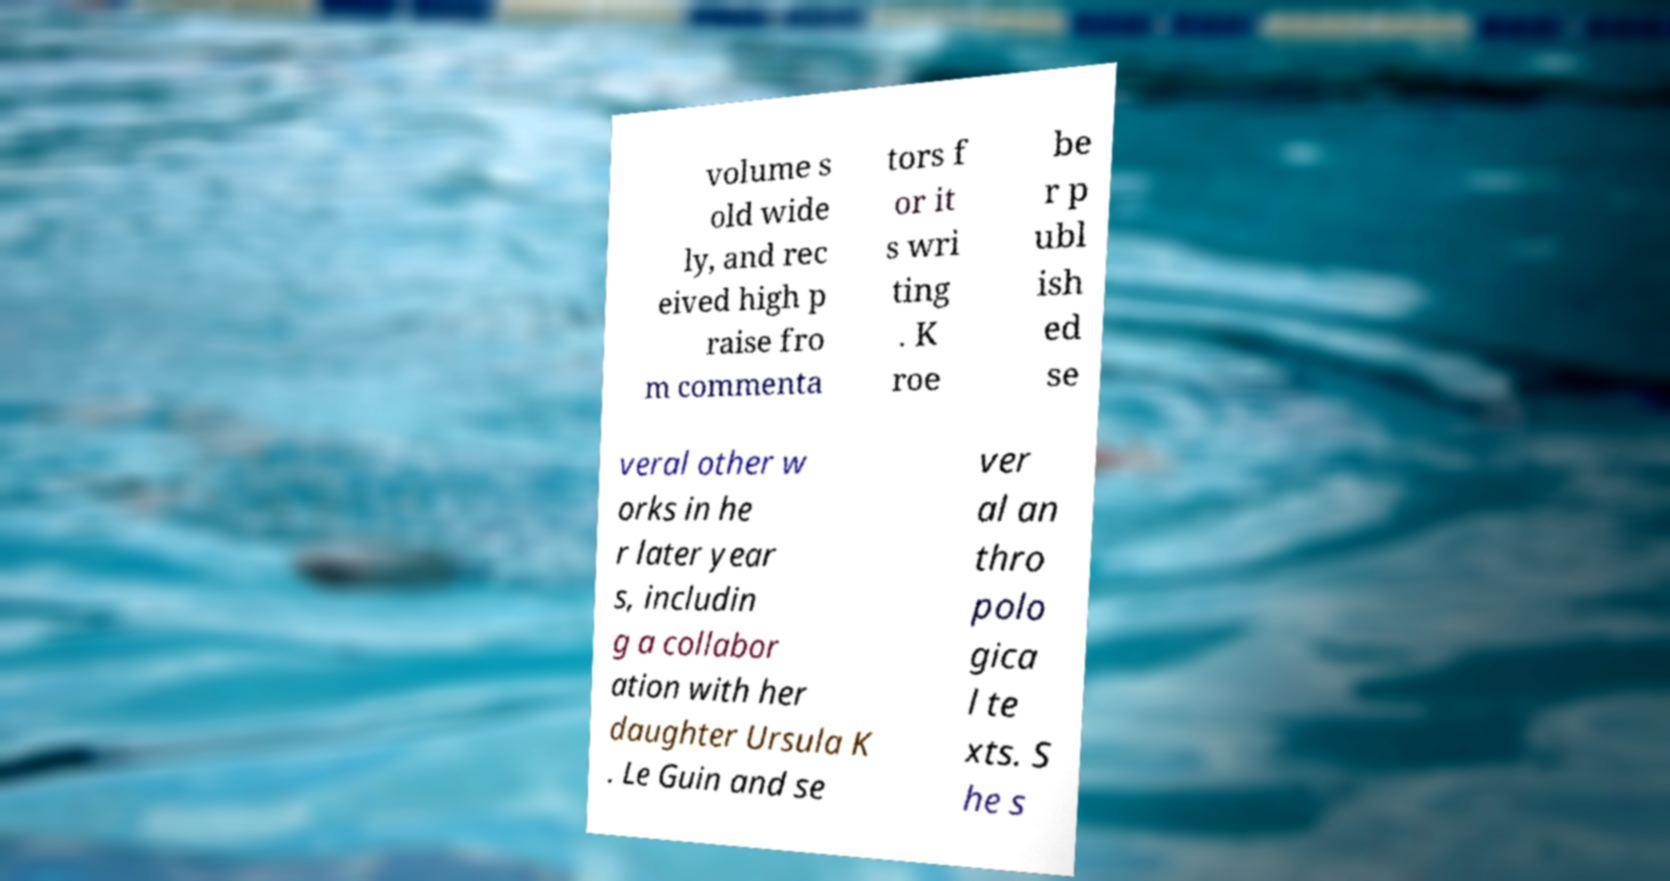What messages or text are displayed in this image? I need them in a readable, typed format. volume s old wide ly, and rec eived high p raise fro m commenta tors f or it s wri ting . K roe be r p ubl ish ed se veral other w orks in he r later year s, includin g a collabor ation with her daughter Ursula K . Le Guin and se ver al an thro polo gica l te xts. S he s 